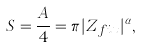<formula> <loc_0><loc_0><loc_500><loc_500>S = \frac { A } { 4 } = \pi | Z _ { f i x } | ^ { \alpha } ,</formula> 